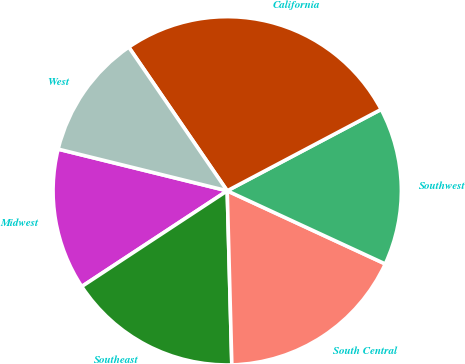<chart> <loc_0><loc_0><loc_500><loc_500><pie_chart><fcel>Midwest<fcel>Southeast<fcel>South Central<fcel>Southwest<fcel>California<fcel>West<nl><fcel>13.11%<fcel>16.16%<fcel>17.68%<fcel>14.64%<fcel>26.82%<fcel>11.59%<nl></chart> 